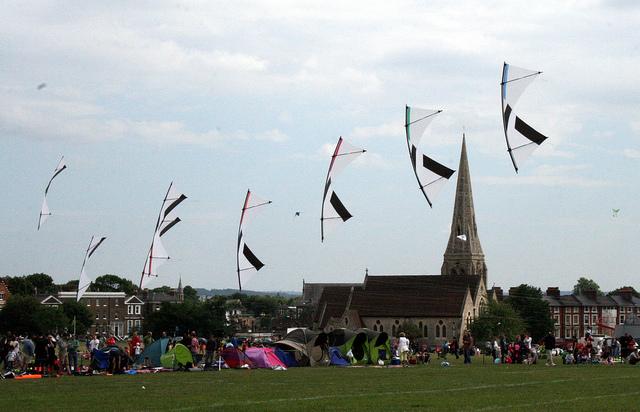What kind of weather is here?
Short answer required. Cloudy. What are the black and white objects in the sky?
Quick response, please. Kites. How many birds are in the picture?
Be succinct. 0. Is this a festival?
Be succinct. Yes. 